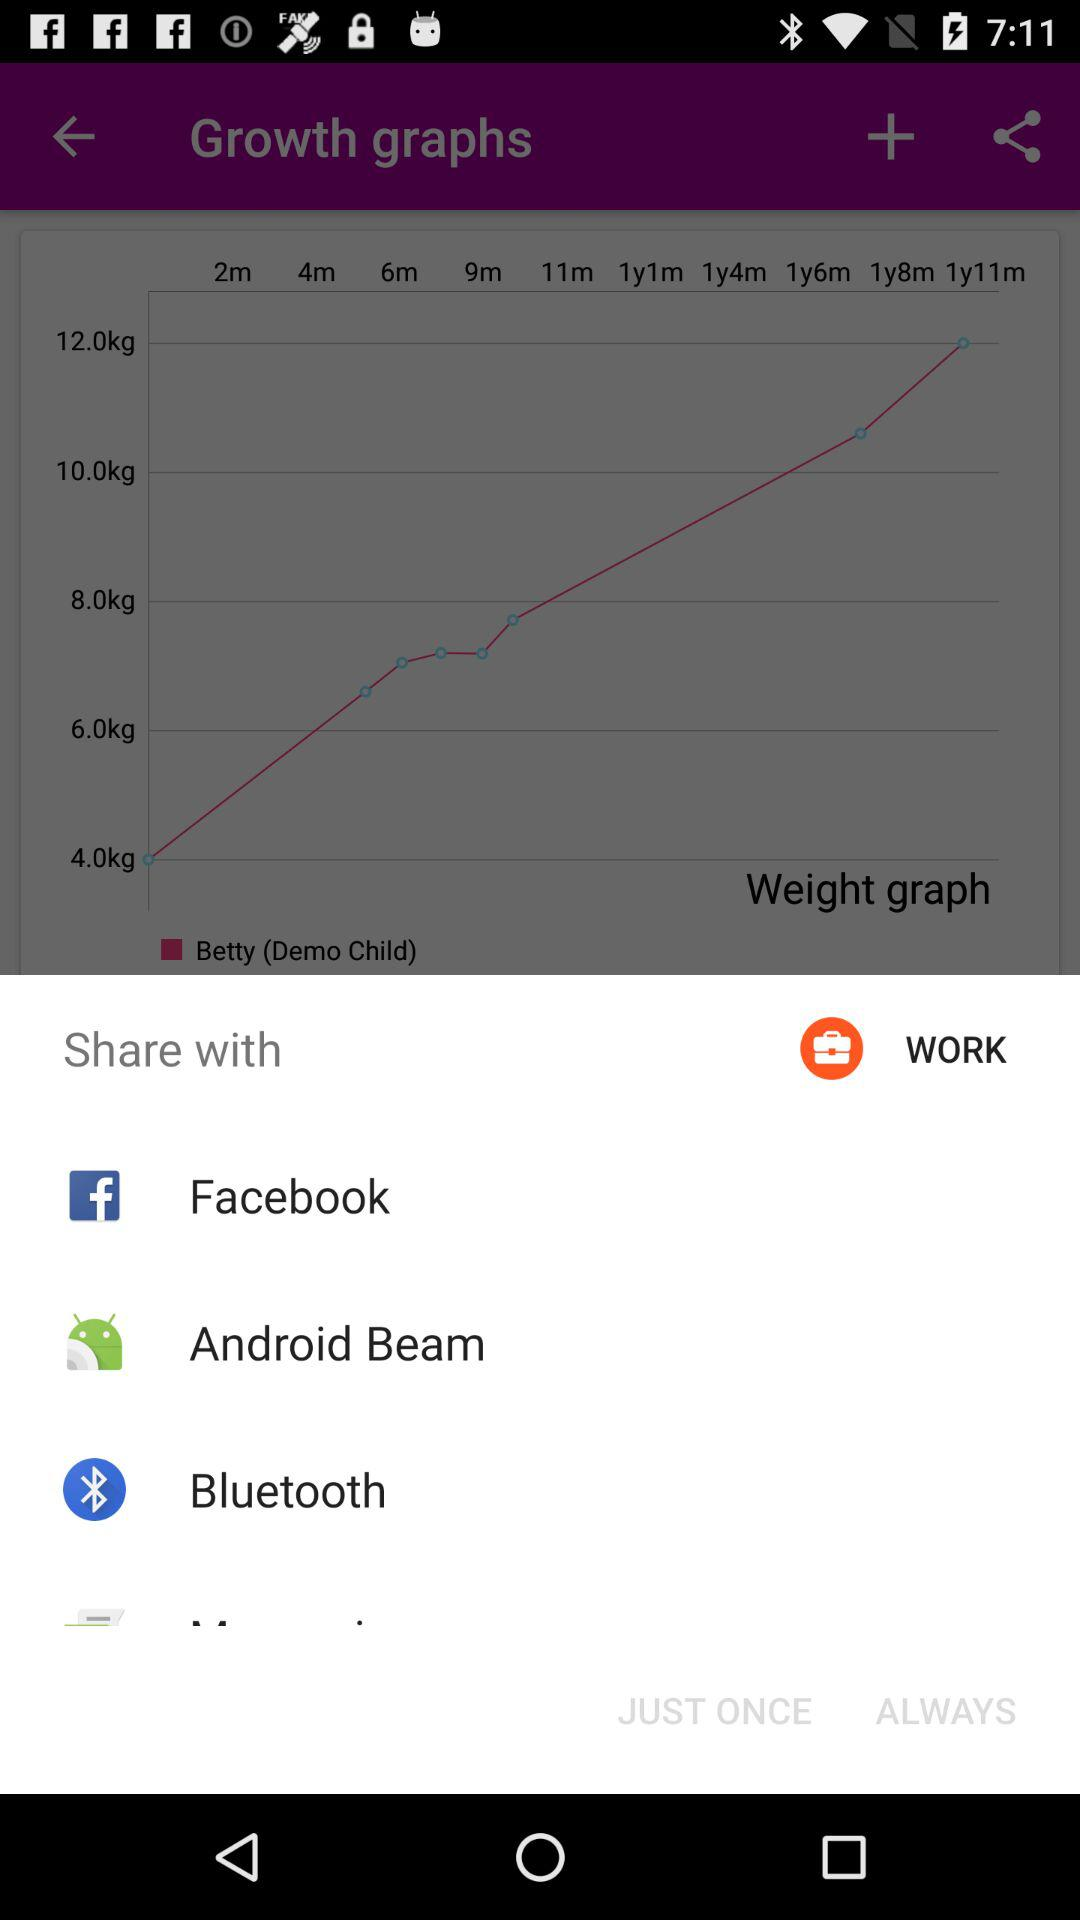How much did Betty weigh in pounds at 4 months?
When the provided information is insufficient, respond with <no answer>. <no answer> 